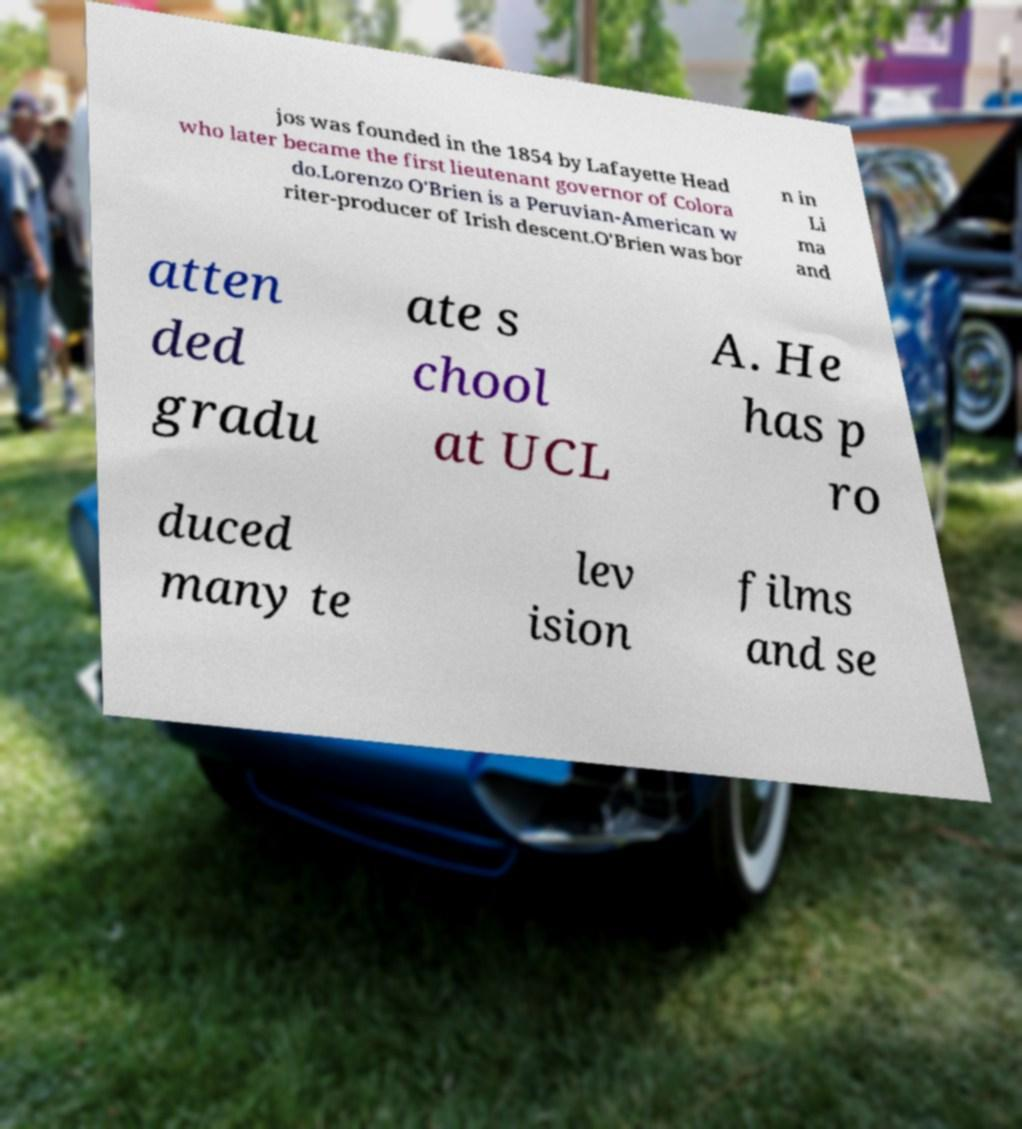For documentation purposes, I need the text within this image transcribed. Could you provide that? jos was founded in the 1854 by Lafayette Head who later became the first lieutenant governor of Colora do.Lorenzo O'Brien is a Peruvian-American w riter-producer of Irish descent.O'Brien was bor n in Li ma and atten ded gradu ate s chool at UCL A. He has p ro duced many te lev ision films and se 